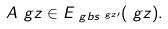<formula> <loc_0><loc_0><loc_500><loc_500>& A ^ { \ } g z \in E _ { \ g b s ^ { \ g z \prime } } ( \ g z ) .</formula> 